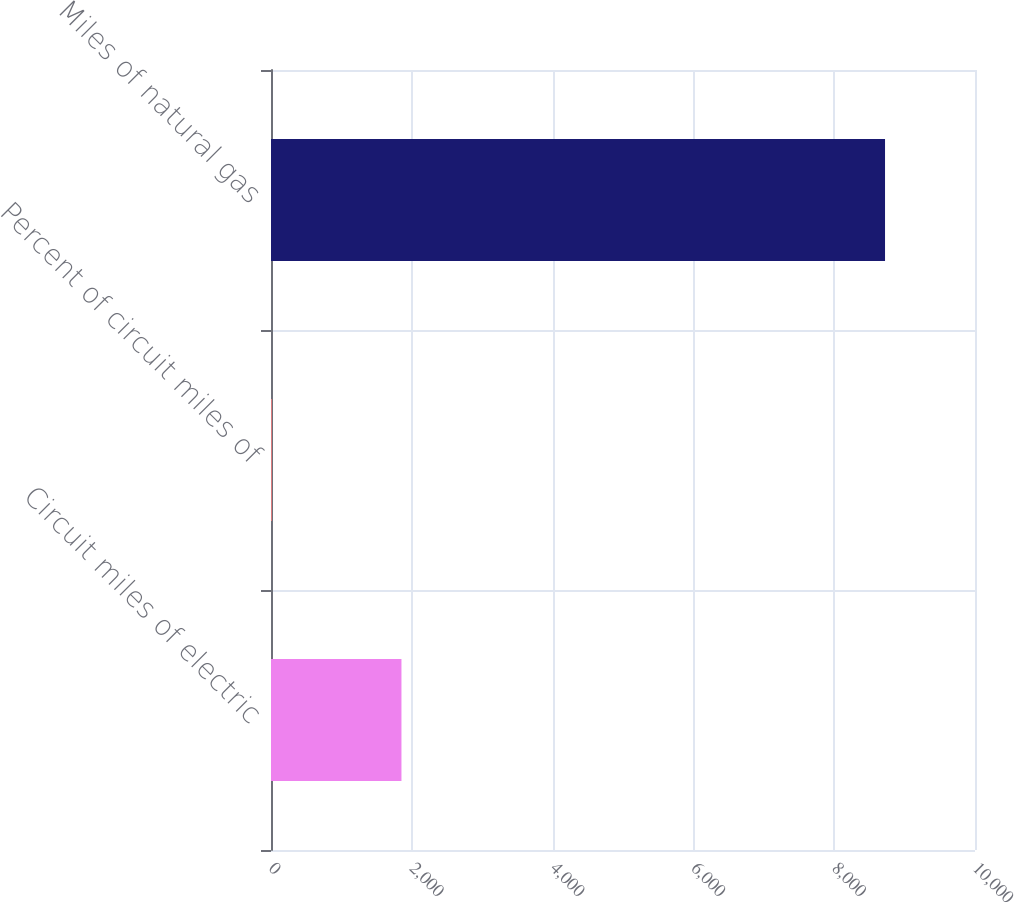Convert chart. <chart><loc_0><loc_0><loc_500><loc_500><bar_chart><fcel>Circuit miles of electric<fcel>Percent of circuit miles of<fcel>Miles of natural gas<nl><fcel>1853<fcel>12<fcel>8722<nl></chart> 